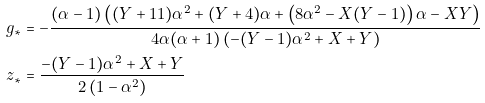Convert formula to latex. <formula><loc_0><loc_0><loc_500><loc_500>g _ { * } & = - \frac { ( \alpha - 1 ) \left ( ( Y + 1 1 ) \alpha ^ { 2 } + ( Y + 4 ) \alpha + \left ( 8 \alpha ^ { 2 } - X ( Y - 1 ) \right ) \alpha - X Y \right ) } { 4 \alpha ( \alpha + 1 ) \left ( - ( Y - 1 ) \alpha ^ { 2 } + X + Y \right ) } \\ z _ { * } & = \frac { - ( Y - 1 ) \alpha ^ { 2 } + X + Y } { 2 \left ( 1 - \alpha ^ { 2 } \right ) }</formula> 